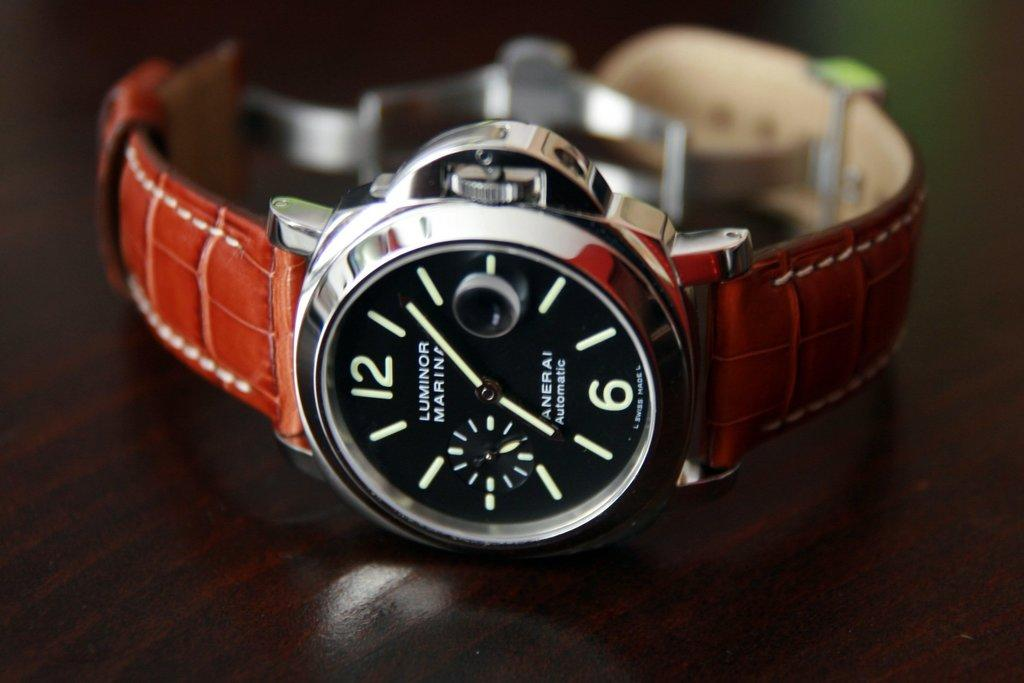<image>
Summarize the visual content of the image. Black watch with a brown strap and the words LUMINOR MARINA. 